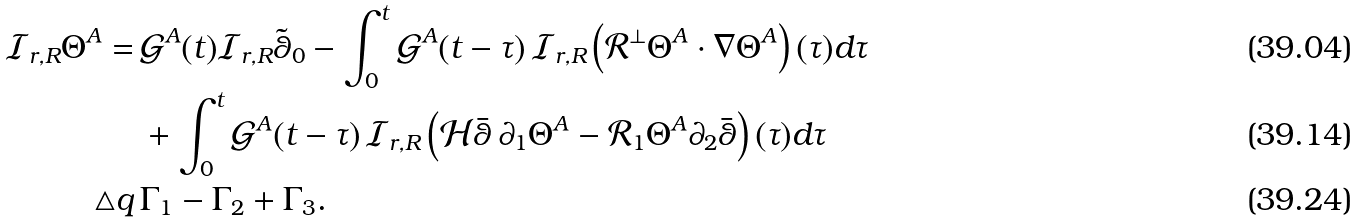<formula> <loc_0><loc_0><loc_500><loc_500>\mathcal { I } _ { r , R } \Theta ^ { A } = \, & \mathcal { G } ^ { A } ( t ) \mathcal { I } _ { r , R } \tilde { \theta } _ { 0 } - \int _ { 0 } ^ { t } \mathcal { G } ^ { A } ( t - \tau ) \, \mathcal { I } _ { r , R } \left ( \mathcal { R } ^ { \perp } \Theta ^ { A } \cdot \nabla \Theta ^ { A } \right ) ( \tau ) d \tau \\ & + \int _ { 0 } ^ { t } \mathcal { G } ^ { A } ( t - \tau ) \, \mathcal { I } _ { r , R } \left ( \mathcal { H } \bar { \theta } \, \partial _ { 1 } \Theta ^ { A } - \mathcal { R } _ { 1 } \Theta ^ { A } \partial _ { 2 } \bar { \theta } \right ) ( \tau ) d \tau \\ \triangle q \, & \Gamma _ { 1 } - \Gamma _ { 2 } + \Gamma _ { 3 } .</formula> 